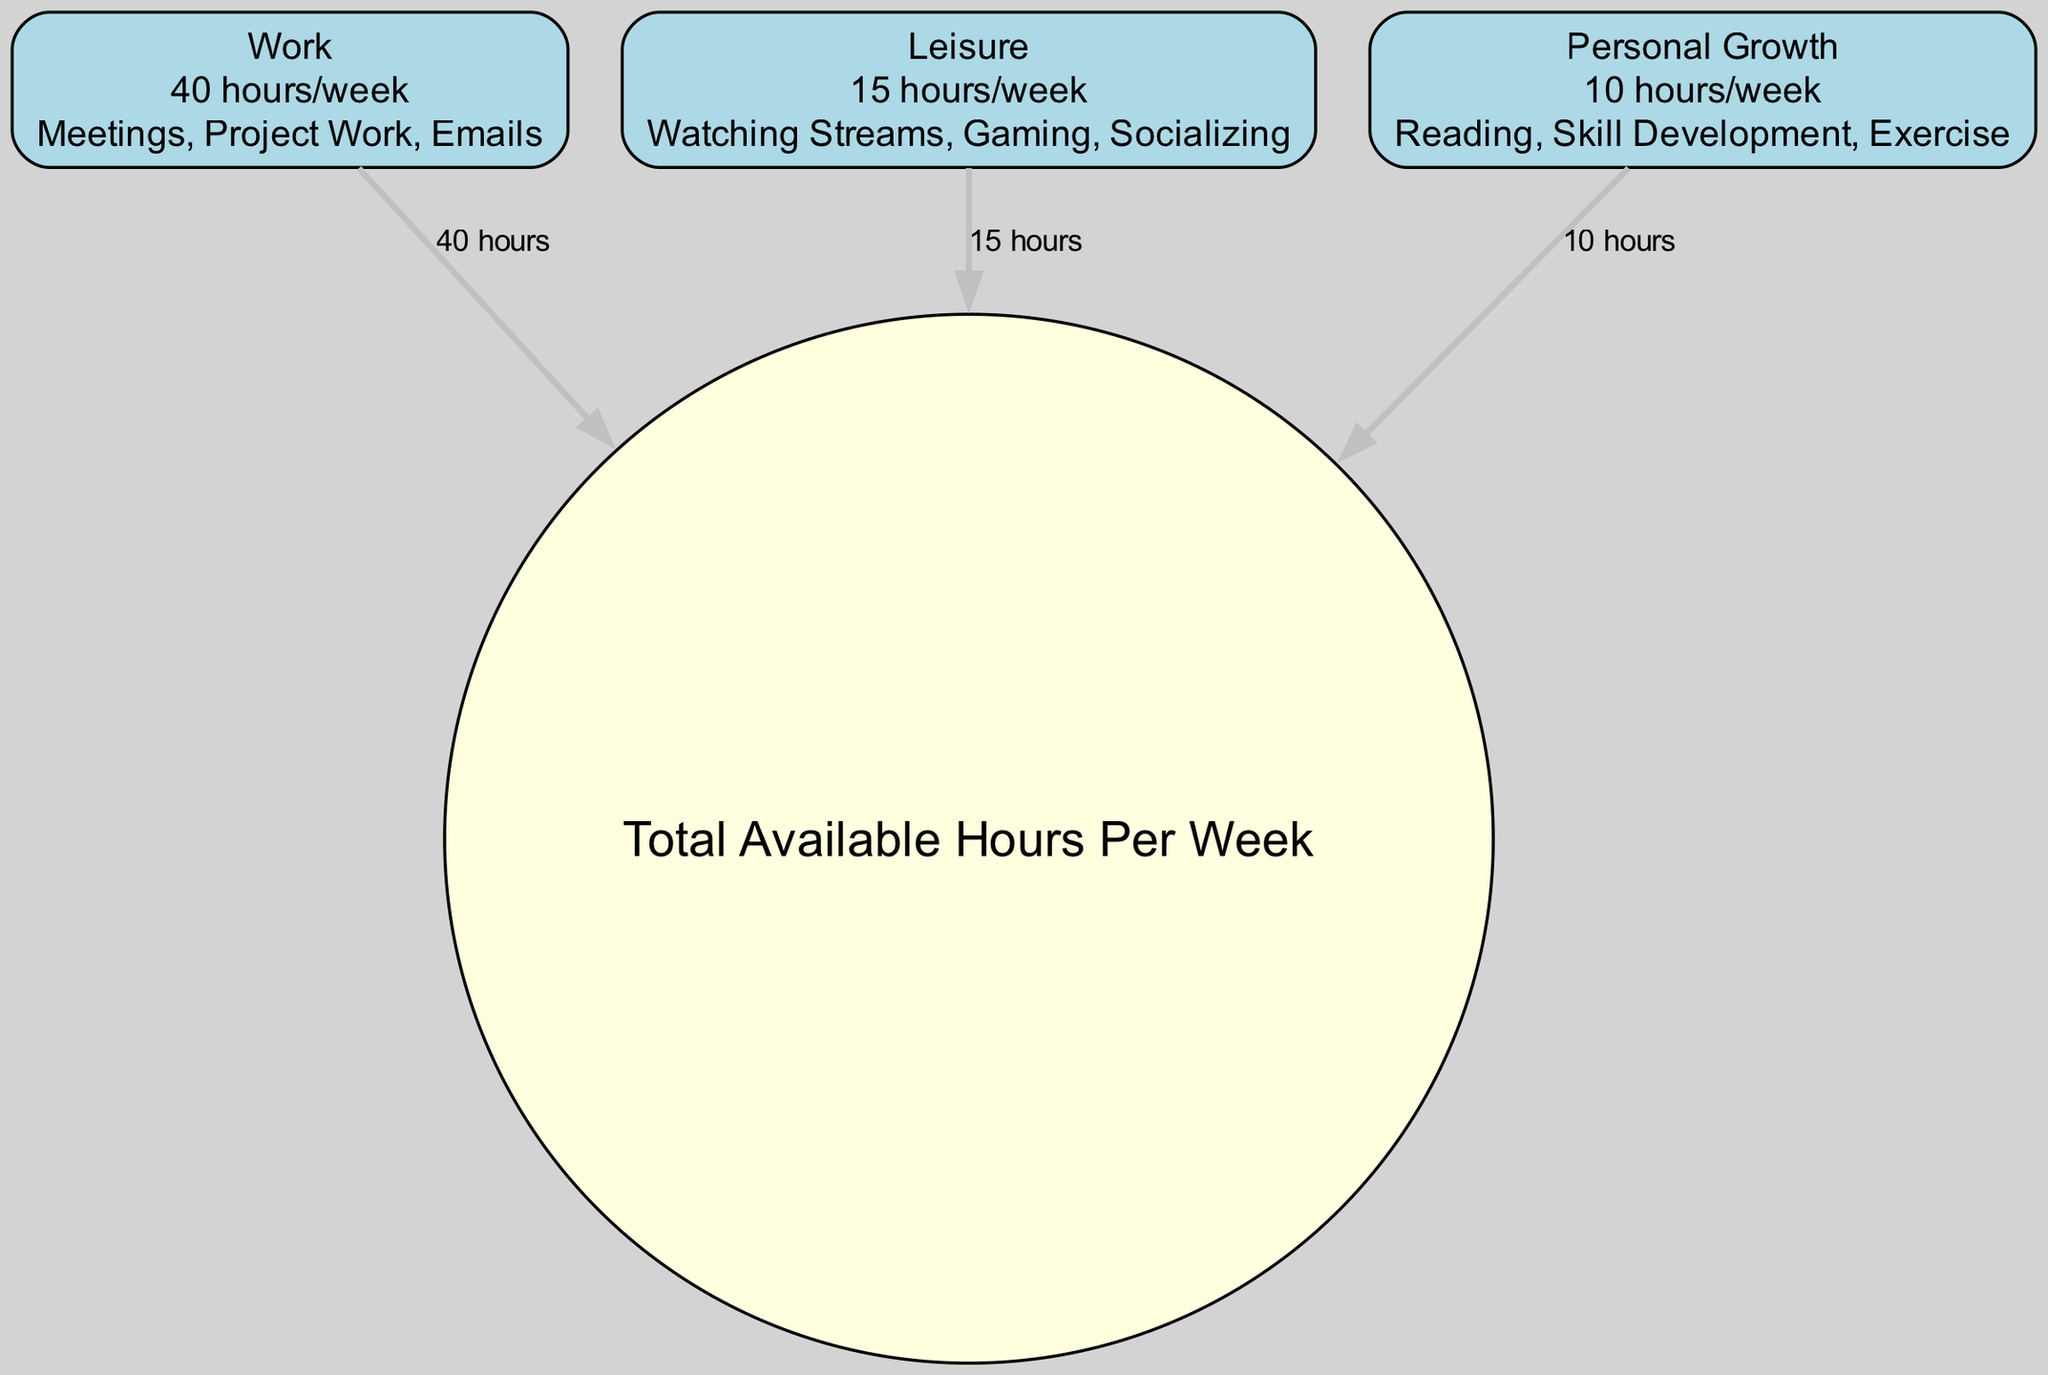What is the total number of hours available in a week? The diagram specifies that the total available hours per week is depicted in the "Total Available Hours Per Week" node. The details of this node state it has a total of 168 hours.
Answer: 168 hours How many hours are allocated for work in a week? Looking at the "Work" node, it shows that the number of hours per week dedicated to work activities is outlined, which is 40 hours.
Answer: 40 hours What is the sum of leisure and personal growth hours? To answer this, I combine the hours from the "Leisure" node (15 hours) and the "Personal Growth" node (10 hours). Adding these two values gives me 15 + 10 = 25 hours.
Answer: 25 hours What activities are included under leisure? The "Leisure" node lists specific activities under its details section, including "Watching Streams," "Gaming," and "Socializing." Therefore, these activities are what comprise leisure time.
Answer: Watching Streams, Gaming, Socializing Which has more hours dedicated: work or personal growth? By comparing the "Work" node, which has 40 hours dedicated to it, with the "Personal Growth" node, which has 10 hours, it is evident that work has significantly more hours assigned.
Answer: Work How many total hours are specified for leisure and work combined? This requires adding the hours in the "Leisure" node (15 hours) to the hours in the "Work" node (40 hours). This calculation amounts to 40 + 15 = 55 hours.
Answer: 55 hours What is the total number of nodes in the diagram? By counting the nodes listed in the provided data, I find that there are four distinct nodes: Work, Leisure, Personal Growth, and Total Available Hours Per Week. Thus, the total is 4.
Answer: 4 How many activities are related to personal growth? The "Personal Growth" node enumerates three activities: "Reading," "Skill Development," and "Exercise." Thus, the total number of activities associated with personal growth is 3.
Answer: 3 What percentage of the total weekly hours is dedicated to leisure? To find the percentage of leisure hours relative to the total available hours, I calculate (15 leisure hours / 168 total hours) * 100, resulting in approximately 8.93%.
Answer: 8.93 percent 